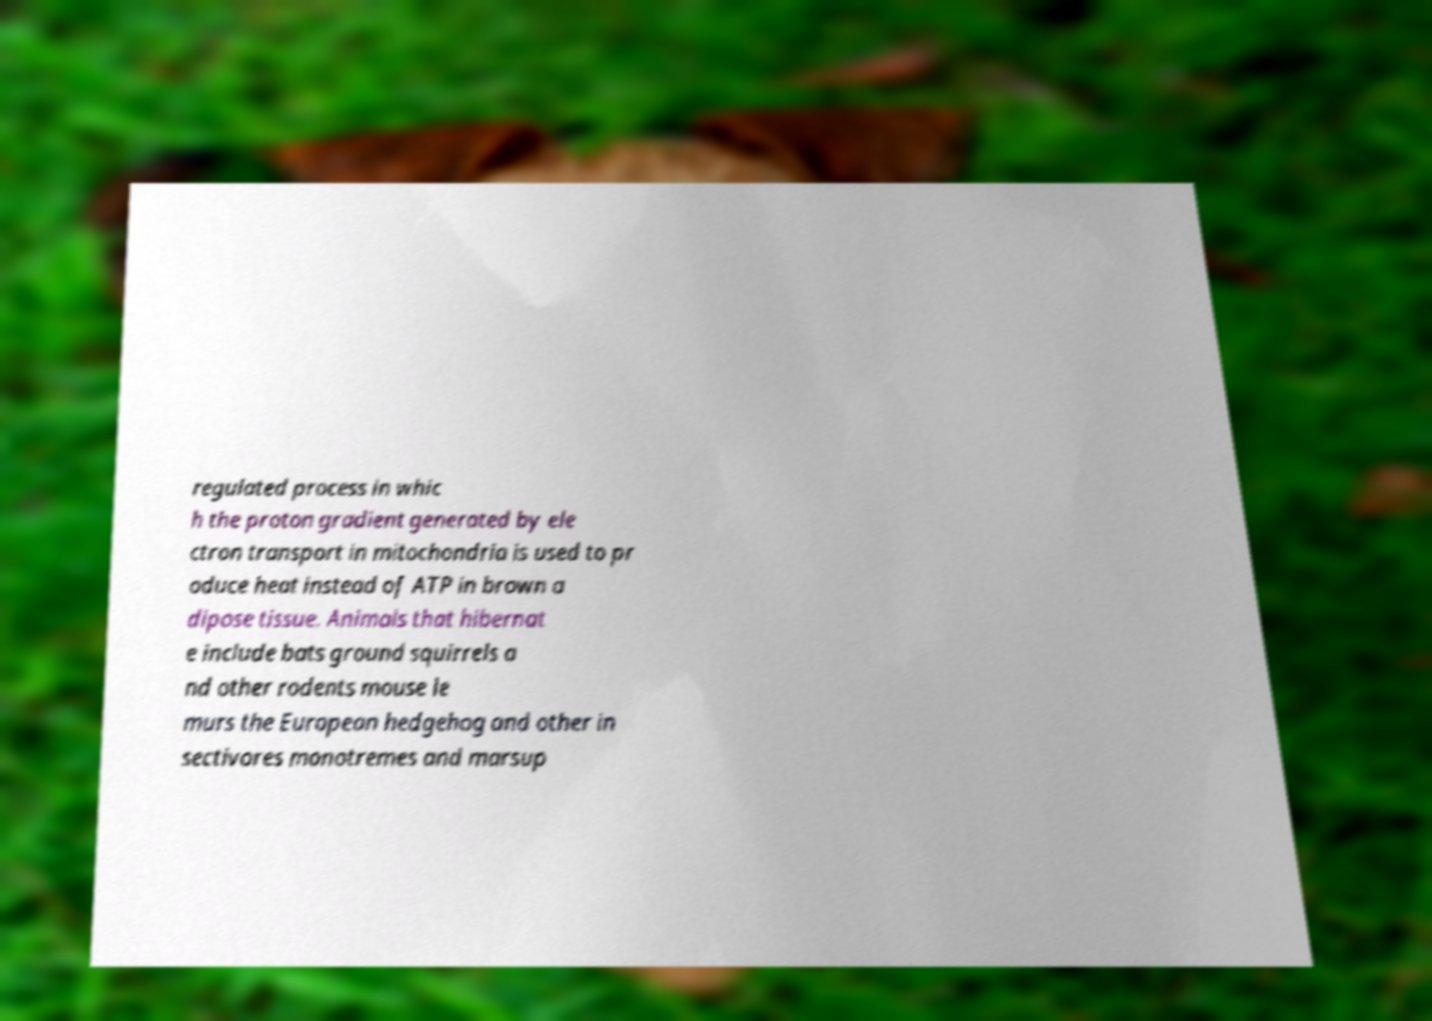Could you assist in decoding the text presented in this image and type it out clearly? regulated process in whic h the proton gradient generated by ele ctron transport in mitochondria is used to pr oduce heat instead of ATP in brown a dipose tissue. Animals that hibernat e include bats ground squirrels a nd other rodents mouse le murs the European hedgehog and other in sectivores monotremes and marsup 